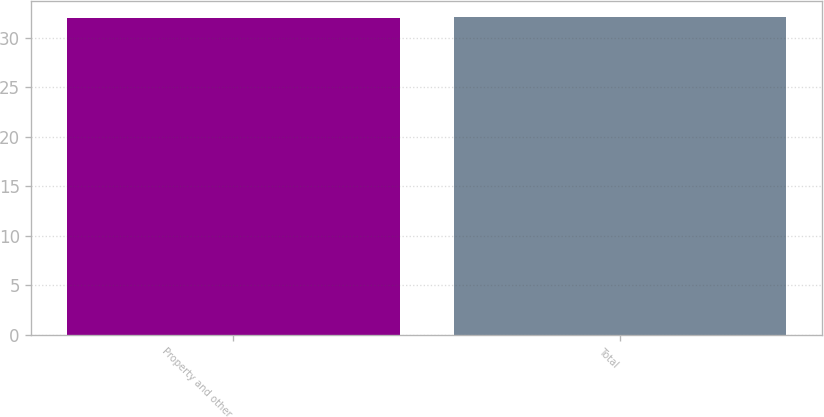Convert chart to OTSL. <chart><loc_0><loc_0><loc_500><loc_500><bar_chart><fcel>Property and other<fcel>Total<nl><fcel>32<fcel>32.1<nl></chart> 